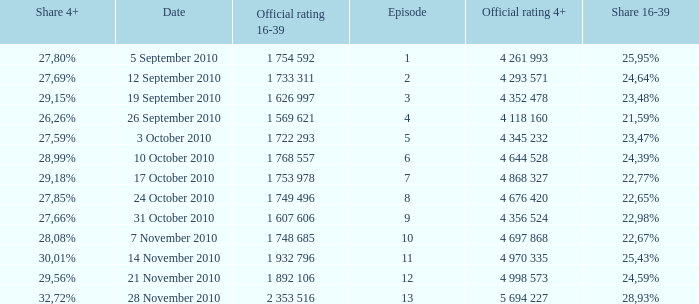What is the official rating 16-39 for the episode with  a 16-39 share of 22,77%? 1 753 978. 